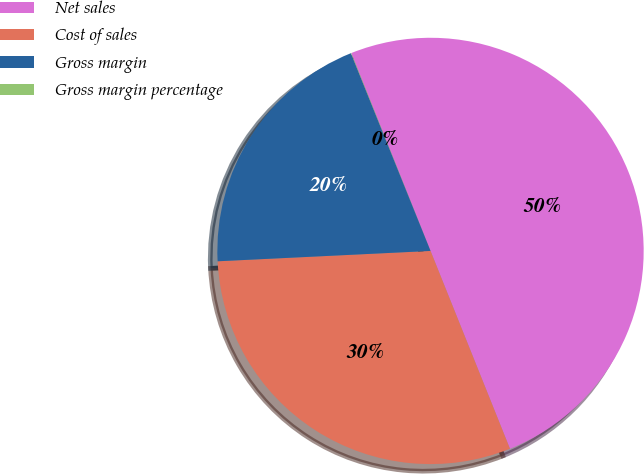Convert chart. <chart><loc_0><loc_0><loc_500><loc_500><pie_chart><fcel>Net sales<fcel>Cost of sales<fcel>Gross margin<fcel>Gross margin percentage<nl><fcel>49.98%<fcel>30.3%<fcel>19.68%<fcel>0.03%<nl></chart> 